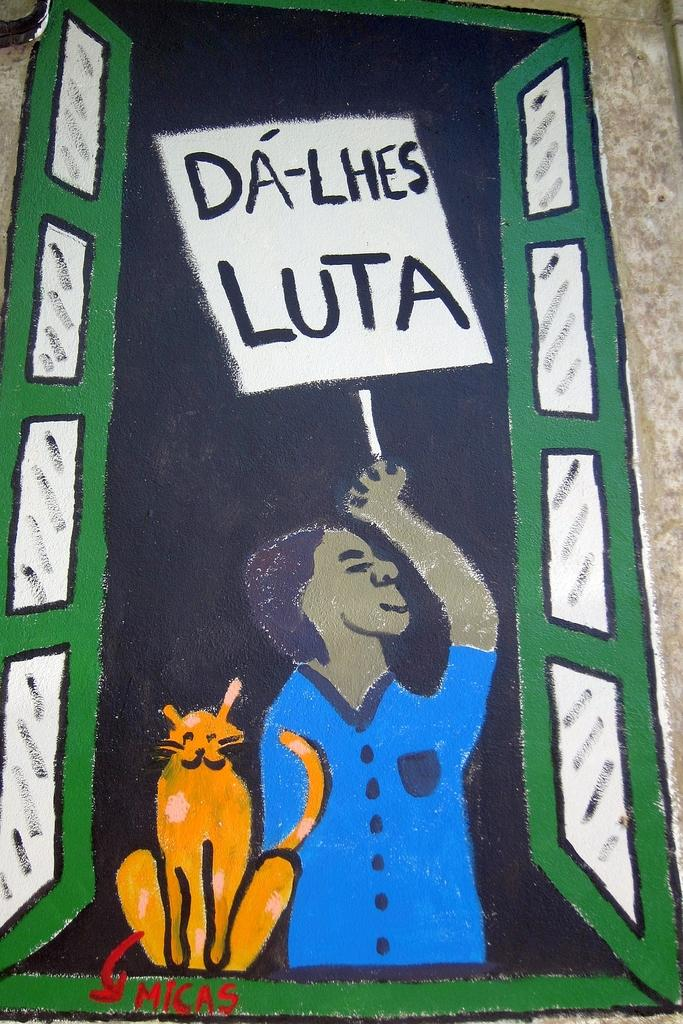What type of artwork is shown in the image? The image appears to be a painting. Can you describe the subjects depicted in the painting? There is a person and an animal depicted in the painting. How many legs does the parcel have in the image? There is no parcel present in the image, so it is not possible to determine how many legs it might have. 